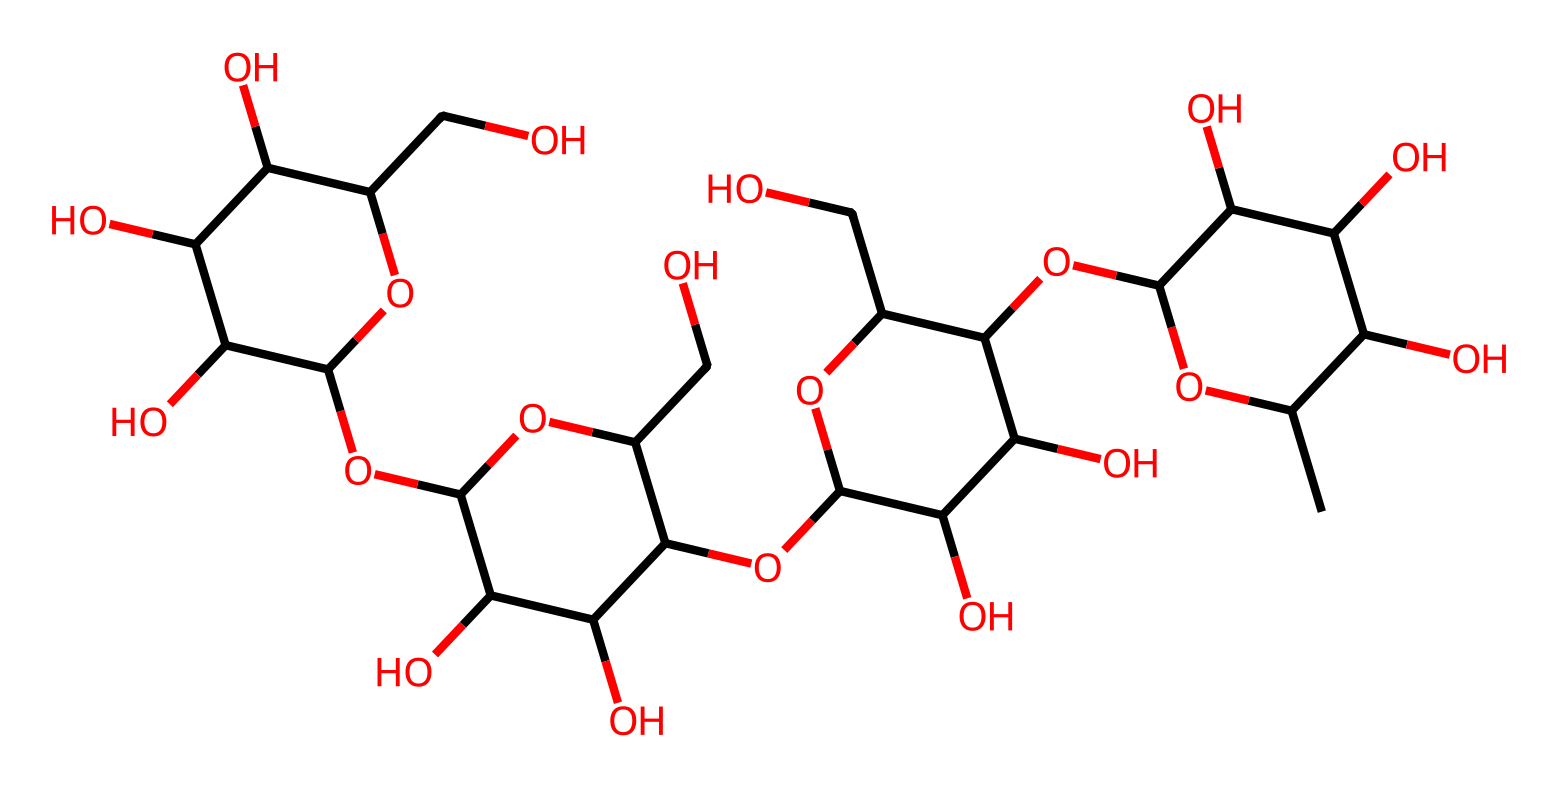What is the molecular formula of xanthan gum? The chemical structure can be analyzed by counting the carbon, hydrogen, and oxygen atoms directly from the SMILES representation. By translating the SMILES, we find there are 35 carbon atoms, 50 hydrogen atoms, and 30 oxygen atoms.
Answer: C35H50O30 How many rings are present in xanthan gum? After examining the structure derived from the SMILES, the number of cyclized structures can be counted. This particular molecule features multiple cyclic structures indicative of its polysaccharide nature. There are a total of four ring structures noted in the molecule.
Answer: 4 What type of bonding primarily holds xanthan gum's structure together? In this molecule, the prevalent type of bonding is glycosidic linkages, which are a result of the linkage between sugars. This can be inferred from the numerous ether and alcohol functional groups representing the bonding between the monosaccharide units.
Answer: glycosidic linkages What property of xanthan gum contributes to its ability to thicken salad dressings? The molecular structure's high viscosity arises from the featured long-chain polysaccharide characteristics, which create a network capable of trapping liquid. This characteristic is key in non-Newtonian fluids, which do not have a constant viscosity.
Answer: viscosity What type of non-Newtonian behavior does xanthan gum exhibit? Xanthan gum typically exhibits shear-thinning behavior, which means its viscosity decreases upon applying shear stress, commonly observed in salad dressings as they are mixed. This property can be confirmed by correlating the molecular arrangement allowing for easier flow under force.
Answer: shear-thinning How does the branching in xanthan gum influence its properties? The branched structure of xanthan gum leads to a greater surface area and more intricate entanglement in solution, enhancing its thickening and stabilizing properties compared to linear polysaccharides. This can be directly associated with understanding the physical behavior of non-Newtonian fluids.
Answer: thickening and stabilizing properties 